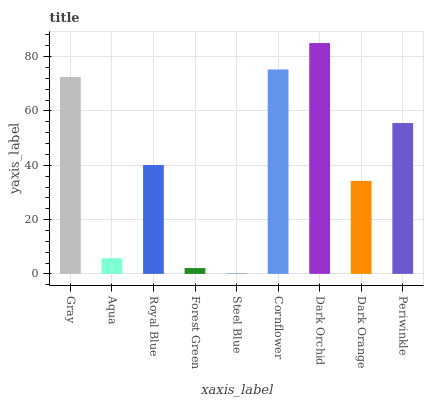Is Steel Blue the minimum?
Answer yes or no. Yes. Is Dark Orchid the maximum?
Answer yes or no. Yes. Is Aqua the minimum?
Answer yes or no. No. Is Aqua the maximum?
Answer yes or no. No. Is Gray greater than Aqua?
Answer yes or no. Yes. Is Aqua less than Gray?
Answer yes or no. Yes. Is Aqua greater than Gray?
Answer yes or no. No. Is Gray less than Aqua?
Answer yes or no. No. Is Royal Blue the high median?
Answer yes or no. Yes. Is Royal Blue the low median?
Answer yes or no. Yes. Is Gray the high median?
Answer yes or no. No. Is Forest Green the low median?
Answer yes or no. No. 